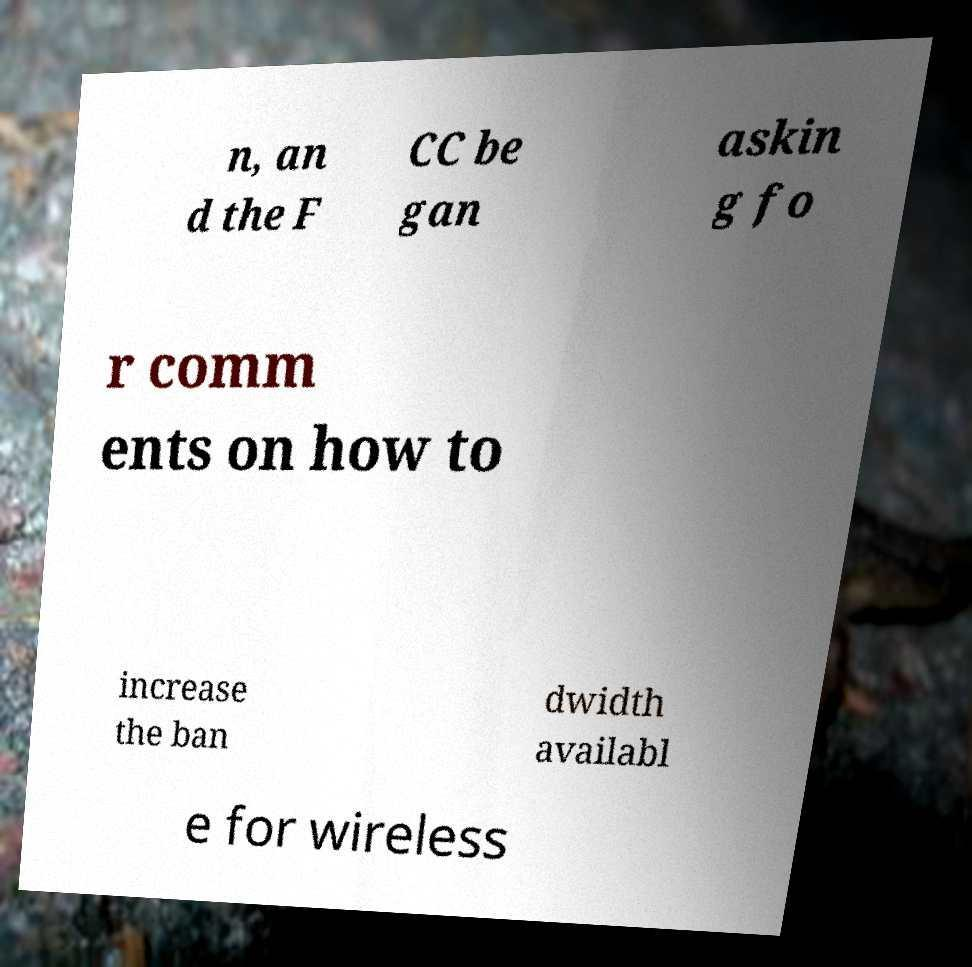There's text embedded in this image that I need extracted. Can you transcribe it verbatim? n, an d the F CC be gan askin g fo r comm ents on how to increase the ban dwidth availabl e for wireless 